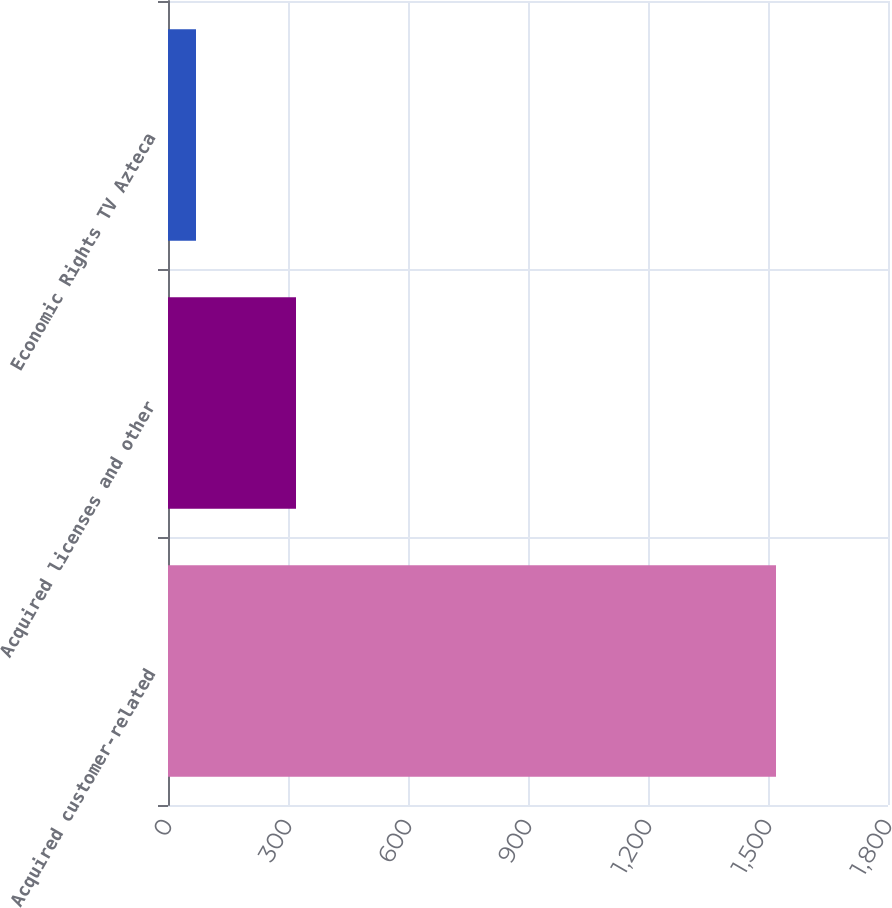Convert chart. <chart><loc_0><loc_0><loc_500><loc_500><bar_chart><fcel>Acquired customer-related<fcel>Acquired licenses and other<fcel>Economic Rights TV Azteca<nl><fcel>1520<fcel>320<fcel>70<nl></chart> 